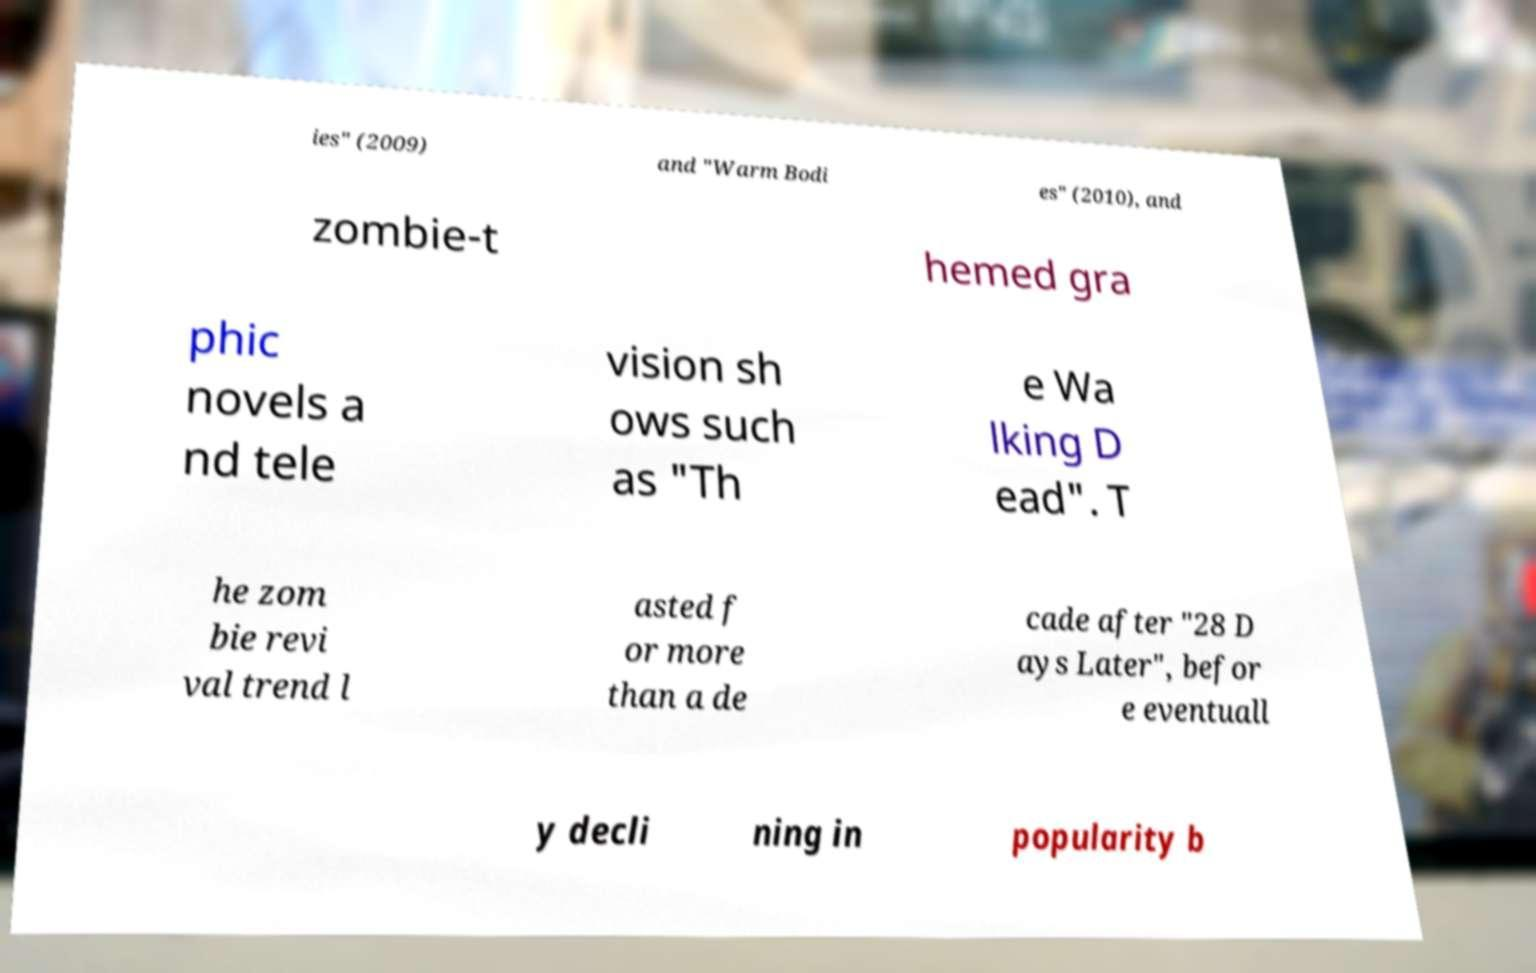Can you read and provide the text displayed in the image?This photo seems to have some interesting text. Can you extract and type it out for me? ies" (2009) and "Warm Bodi es" (2010), and zombie-t hemed gra phic novels a nd tele vision sh ows such as "Th e Wa lking D ead". T he zom bie revi val trend l asted f or more than a de cade after "28 D ays Later", befor e eventuall y decli ning in popularity b 